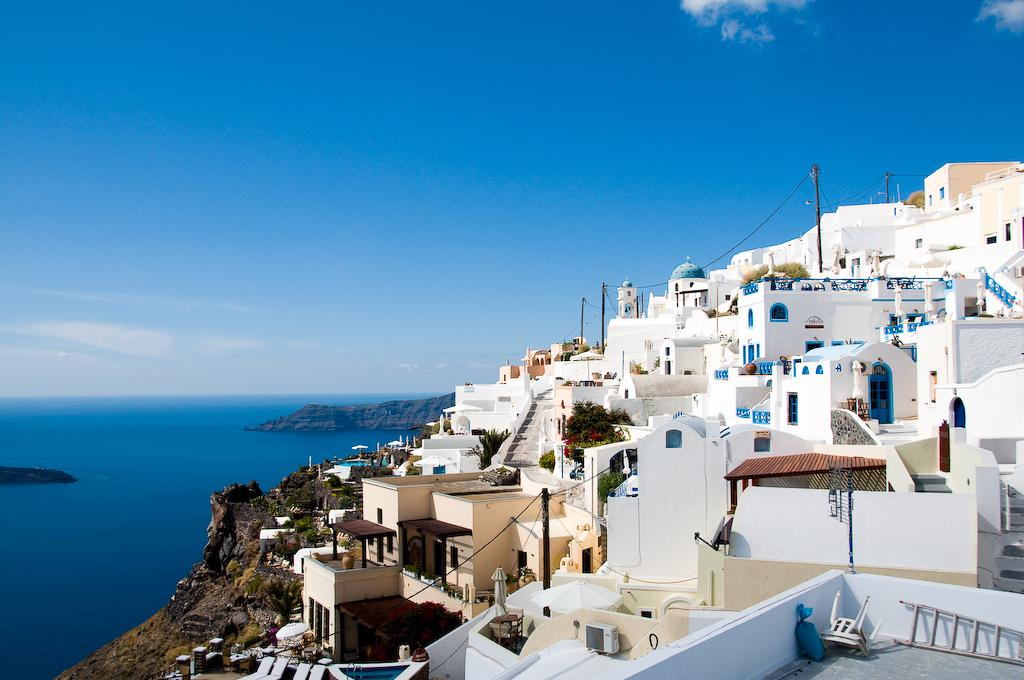What type of furniture can be seen in the image? There are chairs in the image. What is the tall, narrow object in the image? There is a ladder in the image. What structures are visible in the image? There are buildings in the image. What type of vegetation is present in the image? There are trees in the image. What are the long, thin objects in the image? There are poles in the image. What natural element is visible in the image? There is water visible in the image. What can be seen in the background of the image? The sky with clouds is visible in the background of the image. How many toothbrushes are hanging from the poles in the image? There are no toothbrushes present in the image. What type of bikes are parked near the buildings in the image? There are no bikes present in the image. 